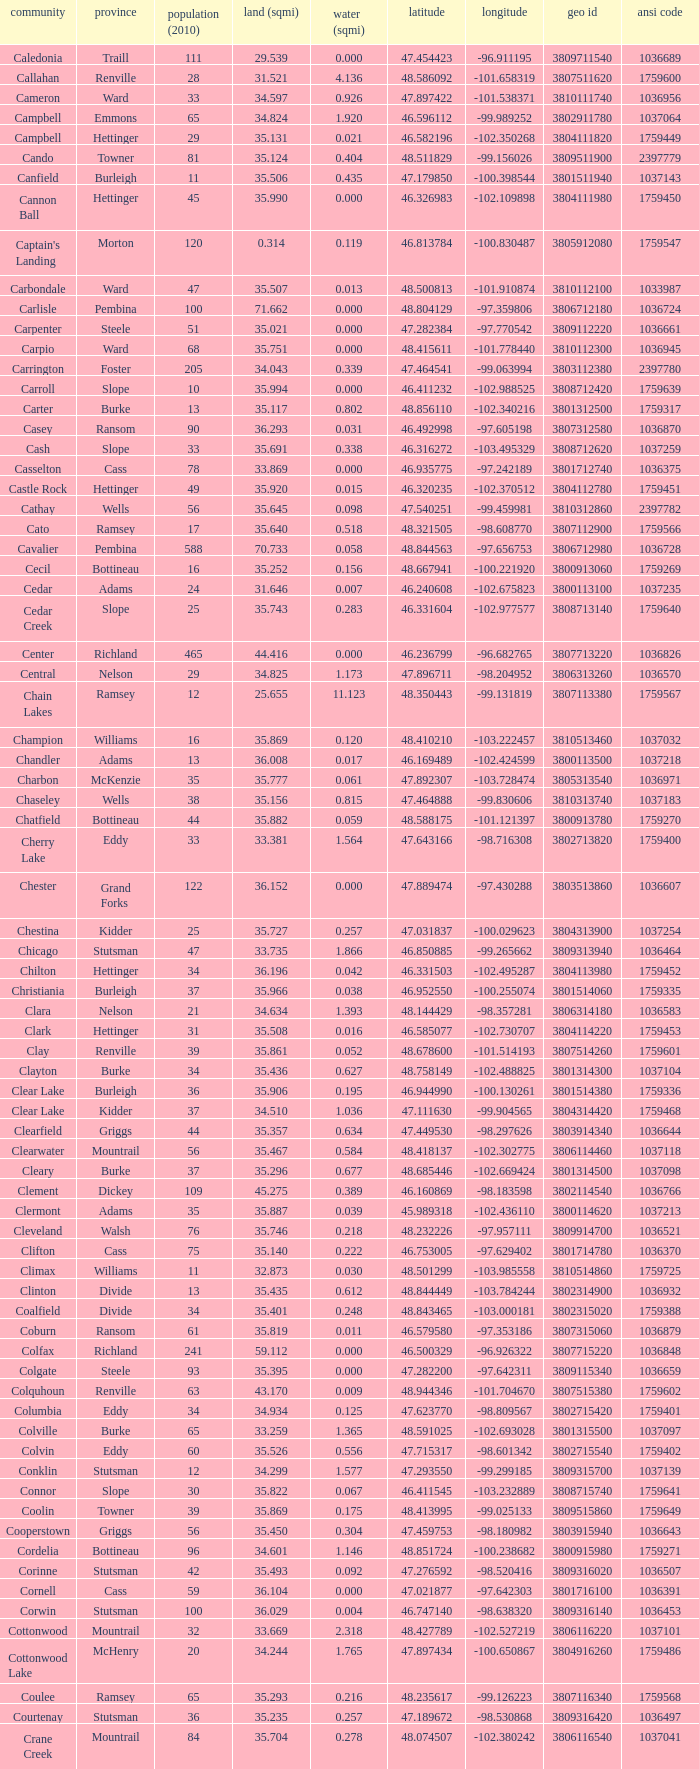Identify the county located at the longitude of -102.302775. Mountrail. 